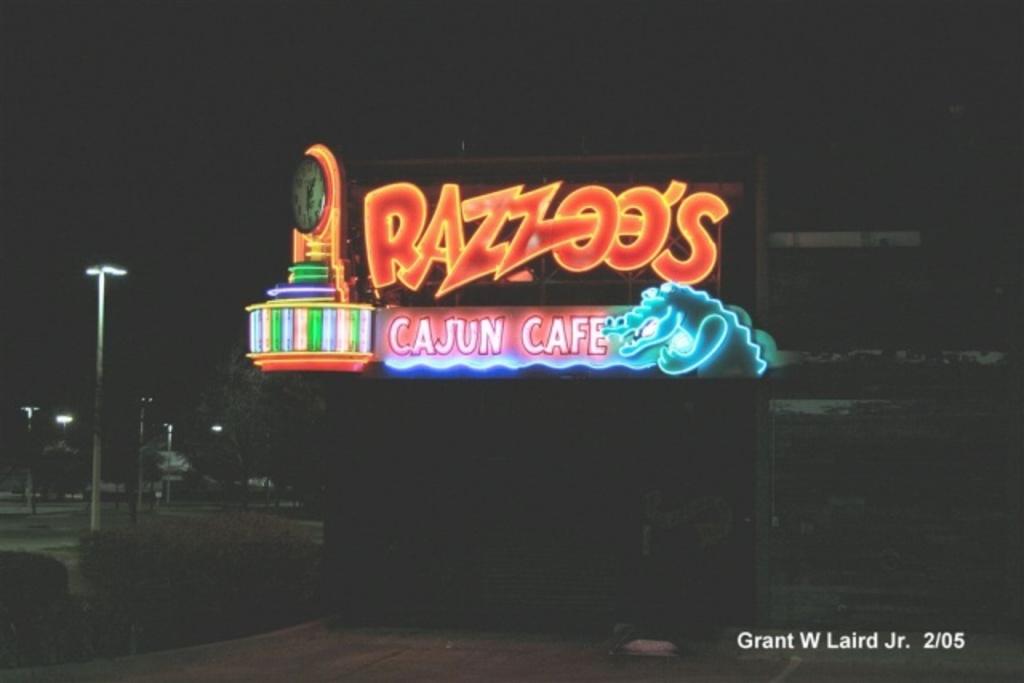What type of food is served at the restaurant?
Offer a very short reply. Cajun. What's the name of the cafe?
Your answer should be very brief. Razzoo's cajun cafe. 